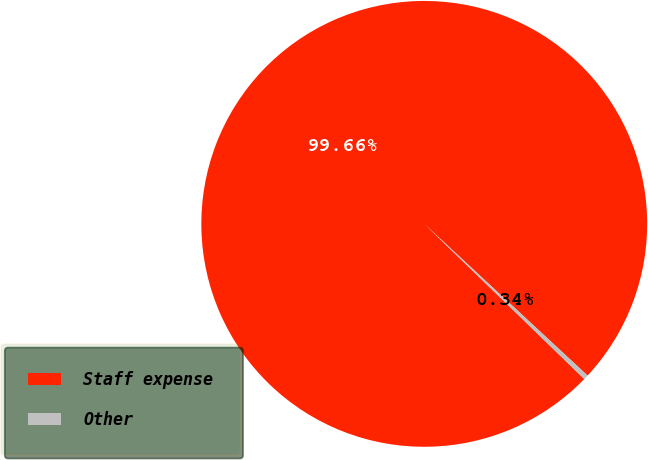Convert chart. <chart><loc_0><loc_0><loc_500><loc_500><pie_chart><fcel>Staff expense<fcel>Other<nl><fcel>99.66%<fcel>0.34%<nl></chart> 